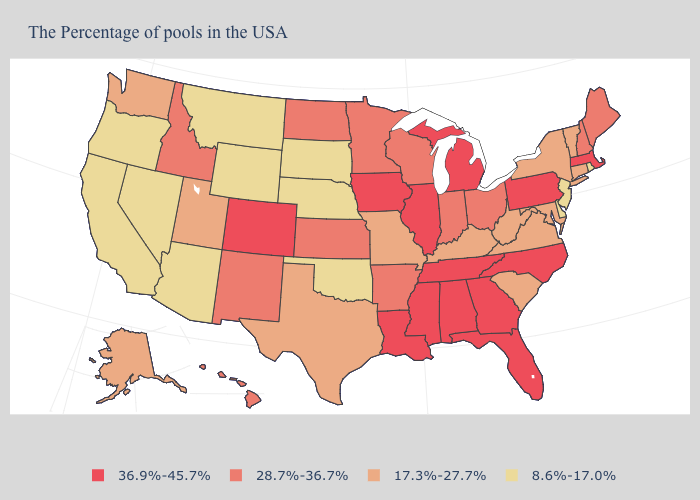What is the highest value in states that border South Dakota?
Give a very brief answer. 36.9%-45.7%. What is the value of Wisconsin?
Quick response, please. 28.7%-36.7%. Which states have the lowest value in the USA?
Write a very short answer. Rhode Island, New Jersey, Delaware, Nebraska, Oklahoma, South Dakota, Wyoming, Montana, Arizona, Nevada, California, Oregon. Name the states that have a value in the range 17.3%-27.7%?
Short answer required. Vermont, Connecticut, New York, Maryland, Virginia, South Carolina, West Virginia, Kentucky, Missouri, Texas, Utah, Washington, Alaska. What is the lowest value in states that border Connecticut?
Give a very brief answer. 8.6%-17.0%. What is the value of Connecticut?
Answer briefly. 17.3%-27.7%. Name the states that have a value in the range 36.9%-45.7%?
Write a very short answer. Massachusetts, Pennsylvania, North Carolina, Florida, Georgia, Michigan, Alabama, Tennessee, Illinois, Mississippi, Louisiana, Iowa, Colorado. What is the value of Iowa?
Quick response, please. 36.9%-45.7%. Does the first symbol in the legend represent the smallest category?
Keep it brief. No. What is the highest value in states that border Oklahoma?
Quick response, please. 36.9%-45.7%. Does Wyoming have the highest value in the USA?
Concise answer only. No. Name the states that have a value in the range 8.6%-17.0%?
Give a very brief answer. Rhode Island, New Jersey, Delaware, Nebraska, Oklahoma, South Dakota, Wyoming, Montana, Arizona, Nevada, California, Oregon. What is the value of Nebraska?
Quick response, please. 8.6%-17.0%. Which states have the highest value in the USA?
Keep it brief. Massachusetts, Pennsylvania, North Carolina, Florida, Georgia, Michigan, Alabama, Tennessee, Illinois, Mississippi, Louisiana, Iowa, Colorado. What is the highest value in the Northeast ?
Be succinct. 36.9%-45.7%. 